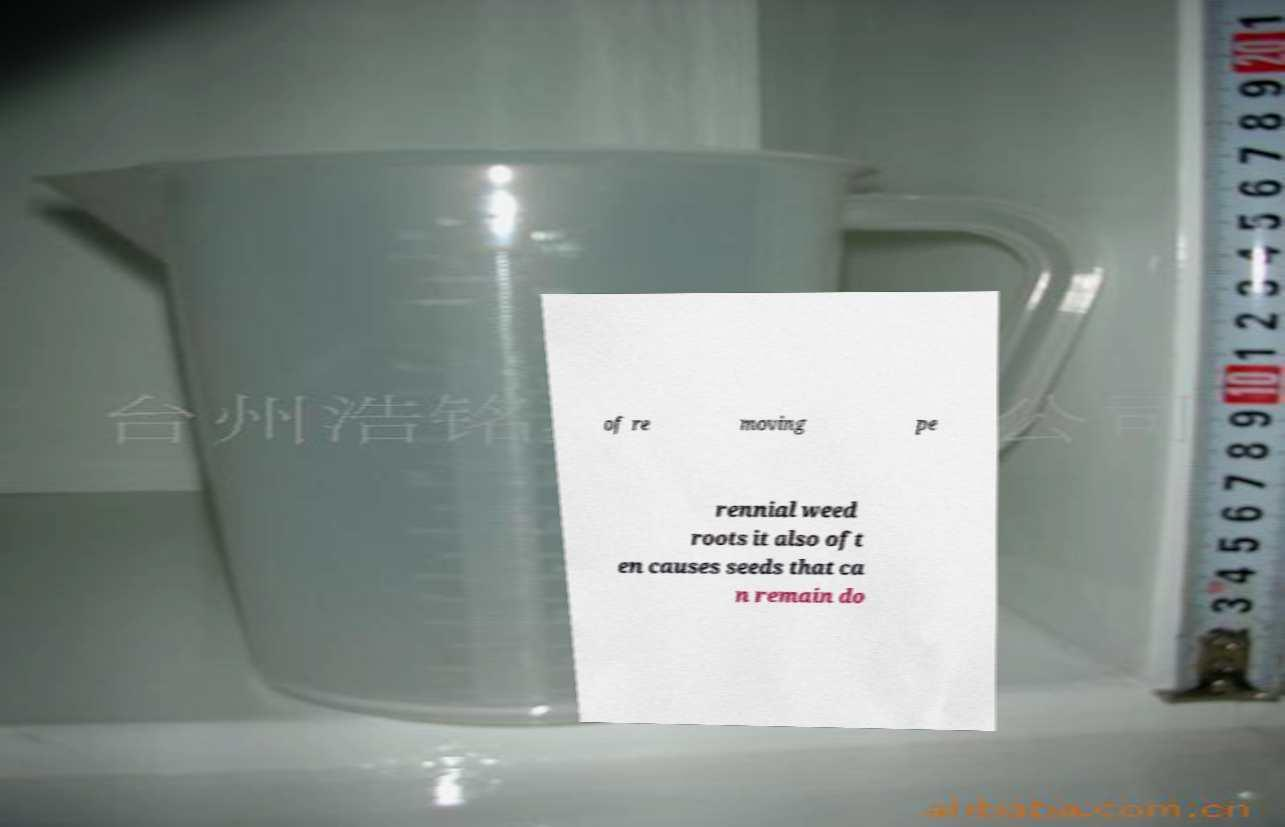There's text embedded in this image that I need extracted. Can you transcribe it verbatim? of re moving pe rennial weed roots it also oft en causes seeds that ca n remain do 